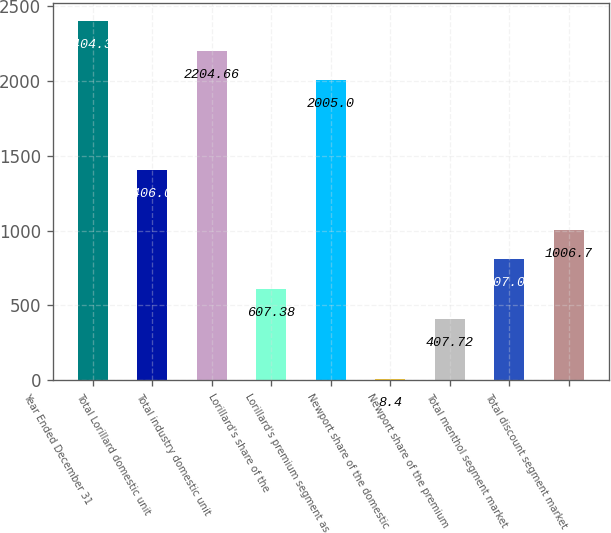Convert chart. <chart><loc_0><loc_0><loc_500><loc_500><bar_chart><fcel>Year Ended December 31<fcel>Total Lorillard domestic unit<fcel>Total industry domestic unit<fcel>Lorillard's share of the<fcel>Lorillard's premium segment as<fcel>Newport share of the domestic<fcel>Newport share of the premium<fcel>Total menthol segment market<fcel>Total discount segment market<nl><fcel>2404.32<fcel>1406.02<fcel>2204.66<fcel>607.38<fcel>2005<fcel>8.4<fcel>407.72<fcel>807.04<fcel>1006.7<nl></chart> 